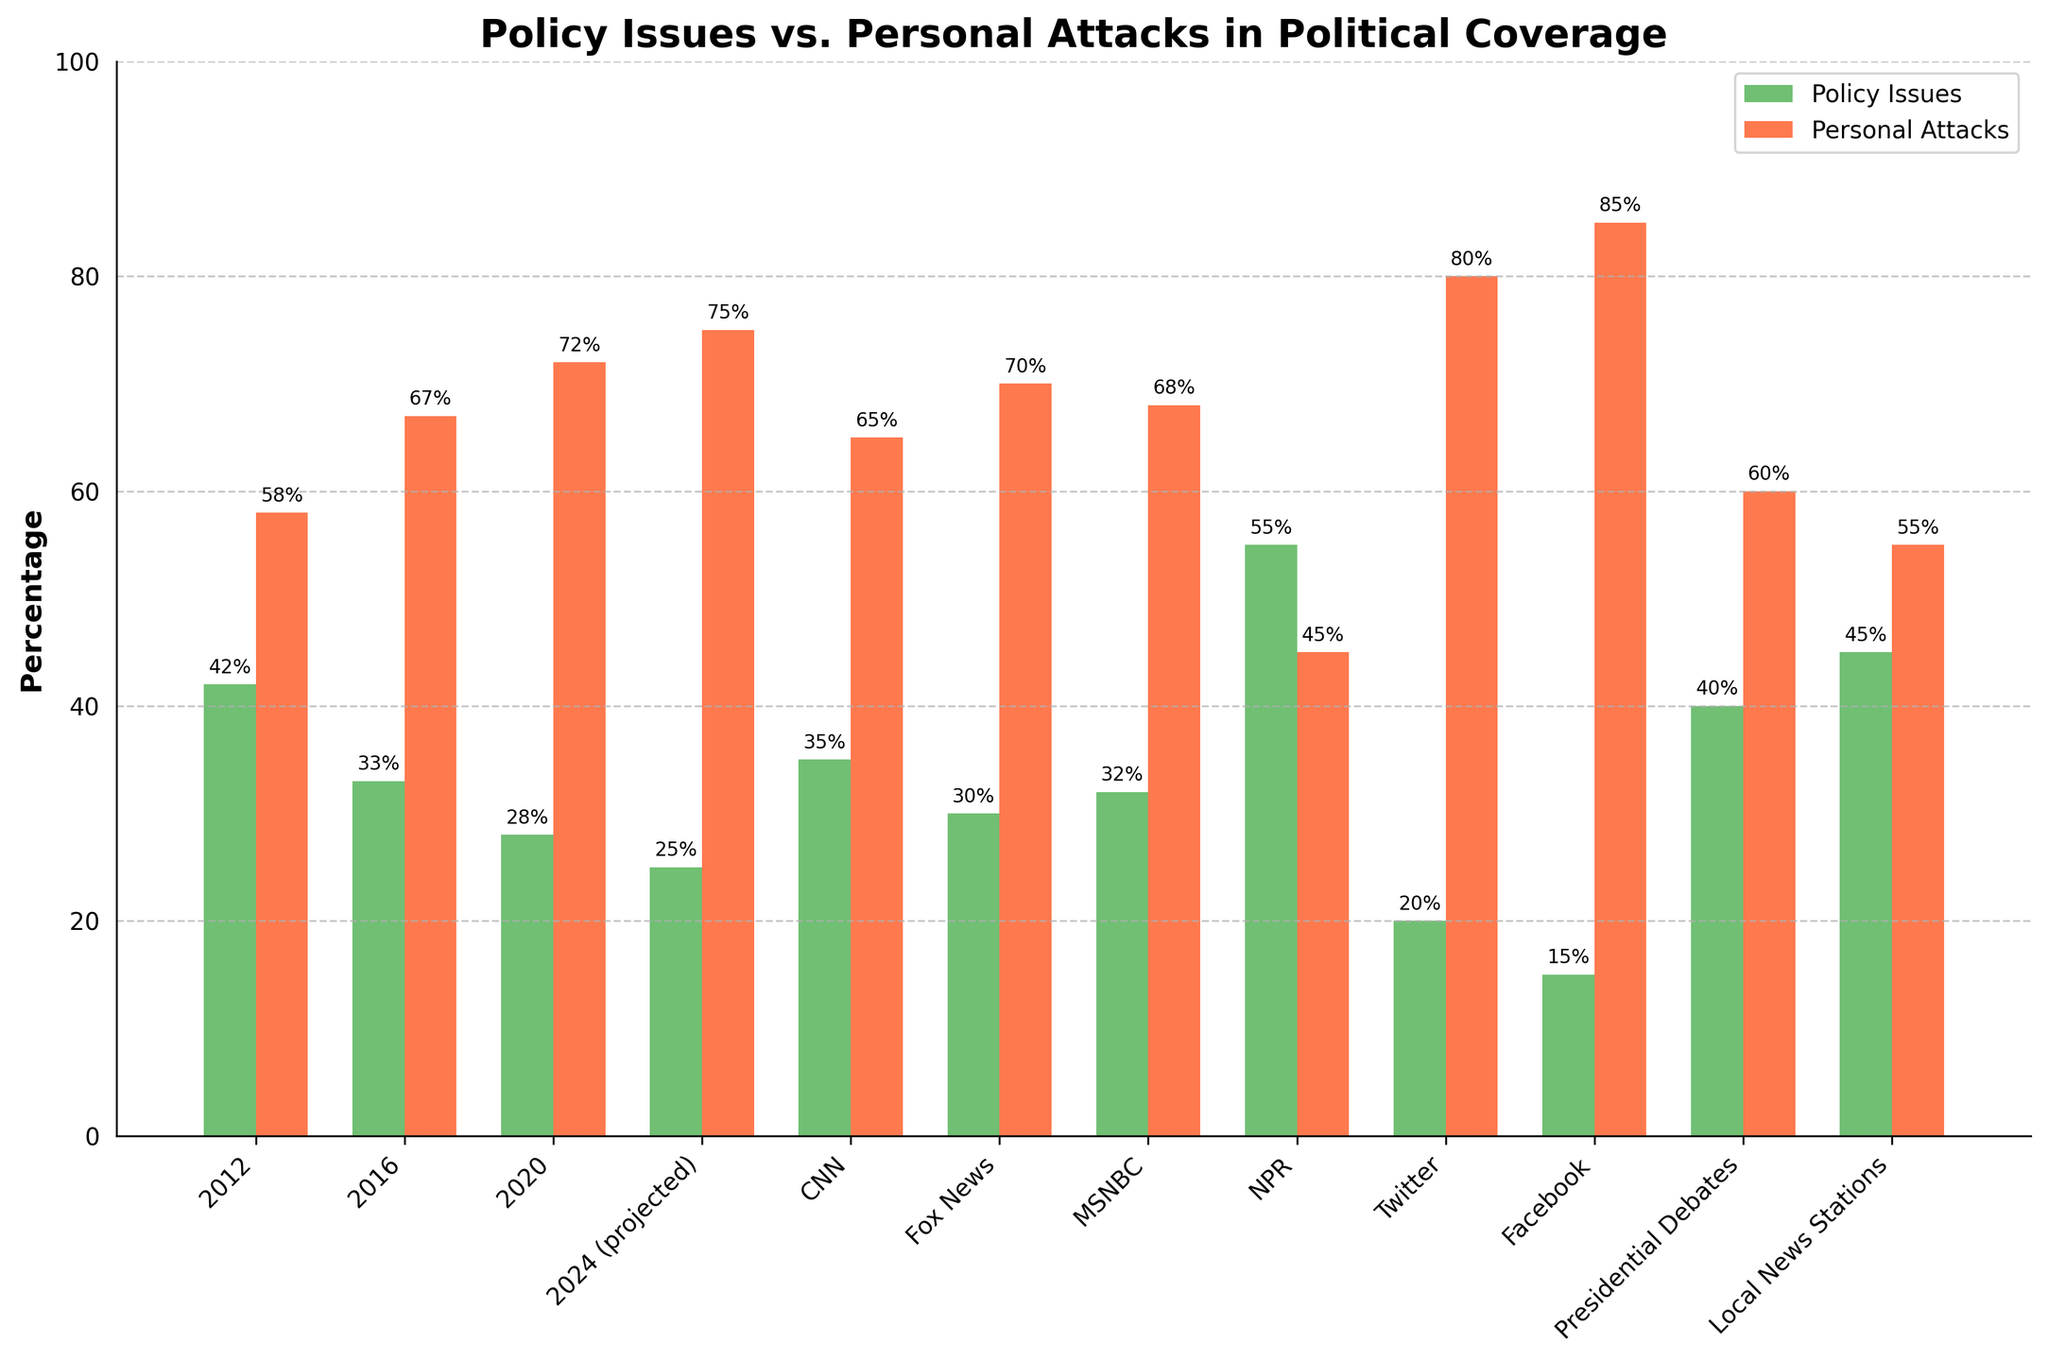what is the difference in percentage points of policy issues coverage between NPR and Fox News? The policy issues coverage for NPR is 55%, and for Fox News, it's 30%. The difference is 55% - 30% = 25%
Answer: 25% Which media outlet has the highest percentage of personal attacks? By comparing the heights of the red bars, Facebook stands out with the highest personal attacks at 85%
Answer: Facebook What is the trend of personal attacks coverage from 2012 to 2024 (projected)? The personal attacks coverage increases over time: 58% in 2012, 67% in 2016, 72% in 2020, and 75% in 2024 (projected)
Answer: Increasing Compare the percentage of policy issues covered between local news stations and CNN. Local news stations cover 45% and CNN covers 35% on policy issues. 45% - 35% = 10%
Answer: Local news stations cover 10% more What is the combined percentage of policy issues covered by Twitter and Facebook? Summing policy issues coverage for Twitter (20%) and Facebook (15%) gives 20% + 15% = 35%
Answer: 35% How much smaller is the policy issues coverage in Facebook compared to the presidential debates? Presidential debates cover 40% and Facebook covers 15% on policy issues. The difference is 40% - 15% = 25%
Answer: 25% smaller Which year has the highest percentage of news coverage devoted to policy issues, and what is that percentage? The bar for 2012 has the highest percent for policy issues at 42%
Answer: 2012, 42% What is the average percentage of policy issues coverage across all sources listed? The sum of percentages for policy issues = 42 + 33 + 28 + 25 + 35 + 30 + 32 + 55 + 20 + 15 + 40 + 45 = 400. There are 12 sources, so the average = 400/12 ≈ 33.33%
Answer: ≈ 33.33% Between CNN and MSNBC, which has a higher percentage of personal attacks, and by how much? Personal attacks: CNN is 65%, and MSNBC is 68%. The difference is 68% - 65% = 3%
Answer: MSNBC by 3% How do the projected percentages of policy issues and personal attacks in 2024 compare to those in 2012? In 2012, policy issues were 42% and personal attacks were 58%. In 2024 (projected), policy issues are 25% and personal attacks 75%. The difference for policy issues is 42% - 25% = 17%, and for personal attacks, 75% - 58% = 17%
Answer: Policy: 17% less, Personal: 17% more 